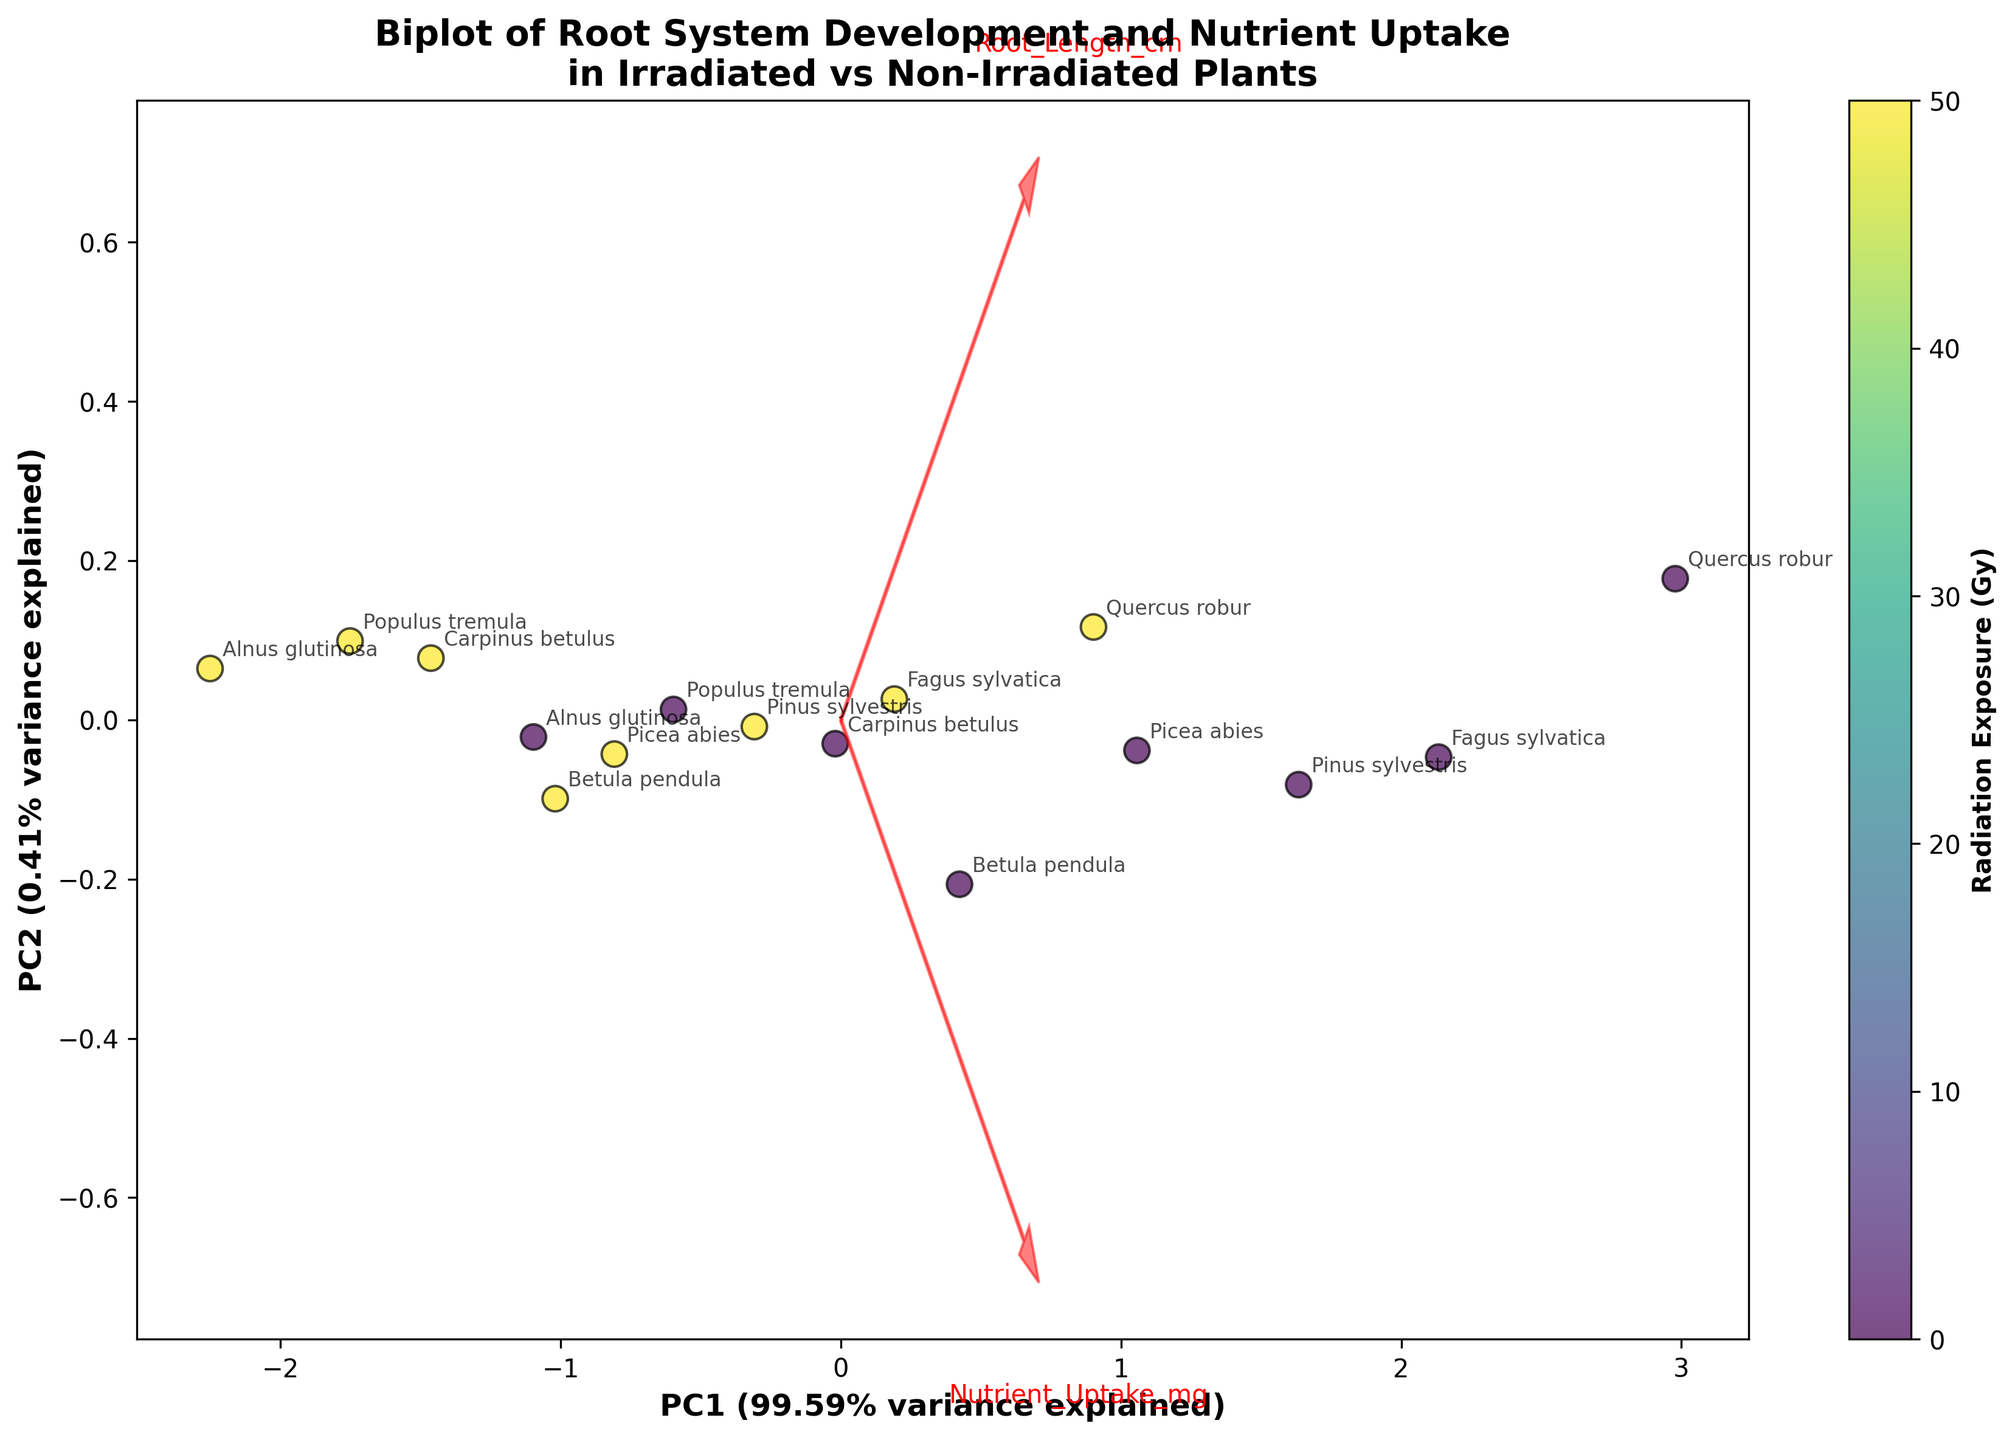What is the title of the figure? The title is the large text usually at the top of the figure. In this case, it is written to describe the content of the biplot, which is about root system development and nutrient uptake in irradiated vs non-irradiated plants.
Answer: Biplot of Root System Development and Nutrient Uptake in Irradiated vs Non-Irradiated Plants What do the arrows represent in the figure? In a biplot, arrows typically represent the original variables. The direction and length of the arrows indicate how each variable contributes to the principal components.
Answer: Root Length (cm) and Nutrient Uptake (mg) Which axis explains more variance in the data? Look at the labels beside each axis; they indicate the percentage of variance explained by each principal component. The axis with the higher percentage explains more variance.
Answer: PC1 How many species data points are shown in the biplot? Count the number of distinct labels or data points. Each species has two data points (irradiated and non-irradiated), so count these to determine the total number.
Answer: 16 How does radiation exposure generally affect root length and nutrient uptake? Compare the irradiated and non-irradiated data points for each species. Typically, irradiated points will have lower values for both variables if radiation negatively impacts the plants.
Answer: Radiation exposure generally reduces root length and nutrient uptake Which plant species appears most affected by radiation in terms of root length? Compare the difference in positions along the PC1 and PC2 axes between irradiated and non-irradiated data points for each species. The species with the largest separation in the root length direction is most affected.
Answer: Quercus robur What percentage of the total variance is explained by the first principal component (PC1)? The percentage of variance explained by PC1 is written beside its axis in the figure.
Answer: 86.70% Which species appears to cluster closely together in the biplot regardless of radiation exposure? Identify the species that show little separation between their irradiated and non-irradiated data points in the biplot.
Answer: Populus tremula Is there a stronger correlation along PC1 or PC2 for root length and nutrient uptake? The variable with the longer arrow along the principal component direction indicates a stronger correlation.
Answer: PC1 Which species has the least nutrient uptake when irradiated? Look for the data point labeled with a species name that is in the lower range of the Nutrient Uptake (mg) dimension.
Answer: Alnus glutinosa 